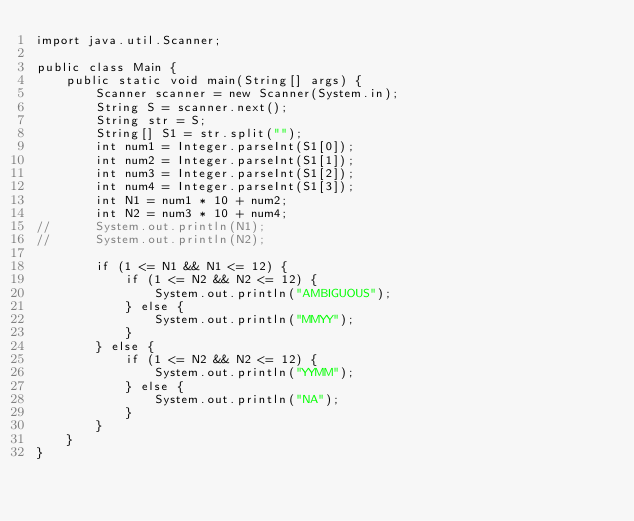Convert code to text. <code><loc_0><loc_0><loc_500><loc_500><_Java_>import java.util.Scanner;

public class Main {
	public static void main(String[] args) {
		Scanner scanner = new Scanner(System.in);
		String S = scanner.next();
		String str = S;
		String[] S1 = str.split("");
		int num1 = Integer.parseInt(S1[0]);
		int num2 = Integer.parseInt(S1[1]);
		int num3 = Integer.parseInt(S1[2]);
		int num4 = Integer.parseInt(S1[3]);
		int N1 = num1 * 10 + num2;
		int N2 = num3 * 10 + num4;
//		System.out.println(N1);
//		System.out.println(N2);
		
		if (1 <= N1 && N1 <= 12) {
			if (1 <= N2 && N2 <= 12) {
				System.out.println("AMBIGUOUS");
			} else {
				System.out.println("MMYY");
			}
		} else {
			if (1 <= N2 && N2 <= 12) {
				System.out.println("YYMM");
			} else {
				System.out.println("NA");
			}
		}
	}
}</code> 